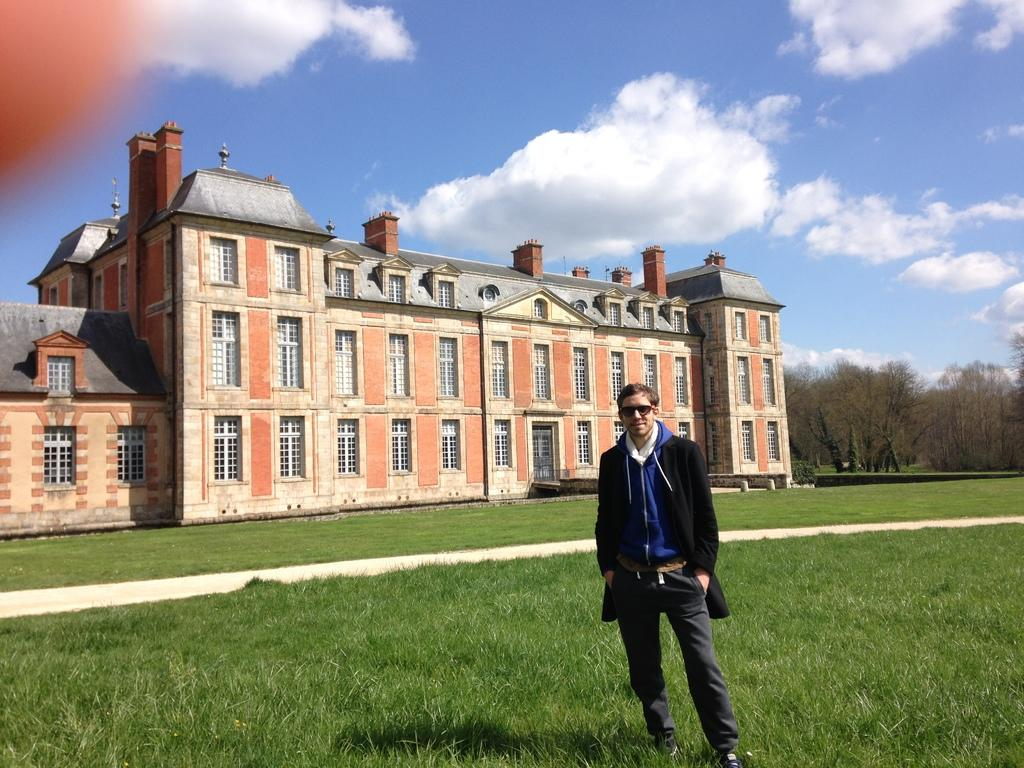Who is present in the image? There is a man in the image. What is the man's location in the image? The man is on the grass. What is the man wearing in the image? The man is wearing goggles. What can be seen in the background of the image? There is a building, trees, and the sky visible in the background of the image. What is the condition of the sky in the image? Clouds are present in the sky. What is the man's profit from the chairs in the image? There are no chairs present in the image, so it is not possible to determine any profit related to chairs. 